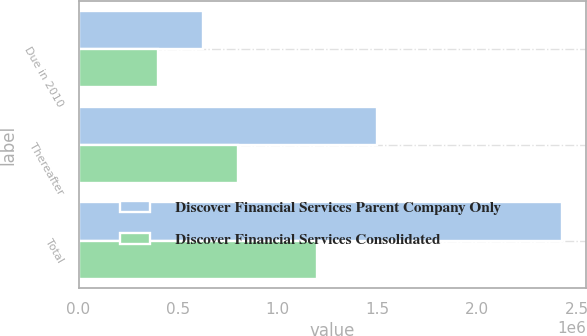<chart> <loc_0><loc_0><loc_500><loc_500><stacked_bar_chart><ecel><fcel>Due in 2010<fcel>Thereafter<fcel>Total<nl><fcel>Discover Financial Services Parent Company Only<fcel>623811<fcel>1.49759e+06<fcel>2.4281e+06<nl><fcel>Discover Financial Services Consolidated<fcel>400000<fcel>799385<fcel>1.19938e+06<nl></chart> 